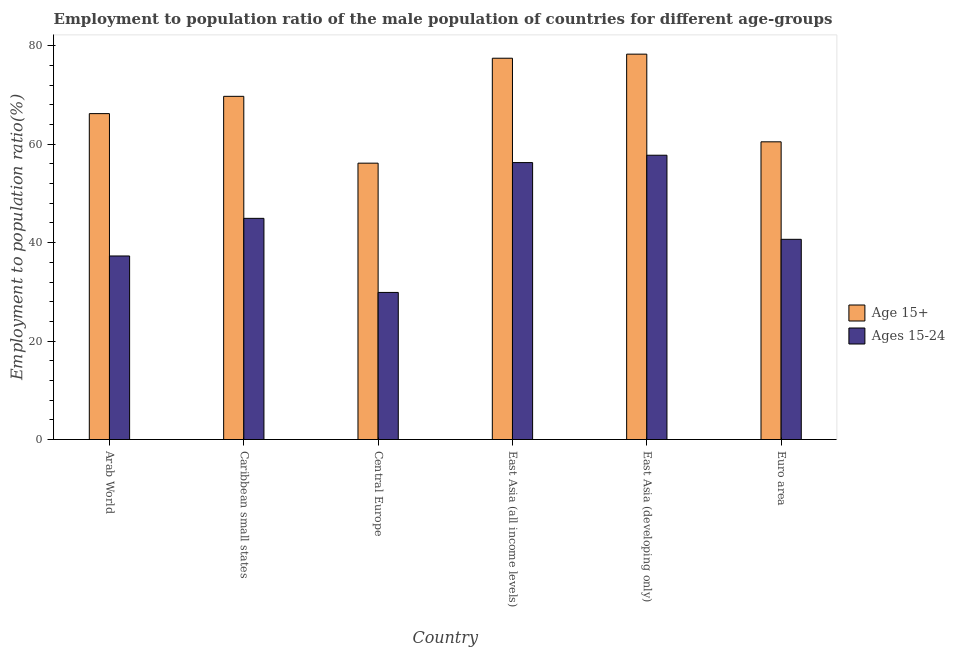How many different coloured bars are there?
Make the answer very short. 2. Are the number of bars on each tick of the X-axis equal?
Your answer should be very brief. Yes. How many bars are there on the 5th tick from the left?
Your answer should be very brief. 2. What is the label of the 2nd group of bars from the left?
Make the answer very short. Caribbean small states. In how many cases, is the number of bars for a given country not equal to the number of legend labels?
Make the answer very short. 0. What is the employment to population ratio(age 15-24) in East Asia (all income levels)?
Your response must be concise. 56.28. Across all countries, what is the maximum employment to population ratio(age 15-24)?
Give a very brief answer. 57.77. Across all countries, what is the minimum employment to population ratio(age 15+)?
Your response must be concise. 56.16. In which country was the employment to population ratio(age 15+) maximum?
Give a very brief answer. East Asia (developing only). In which country was the employment to population ratio(age 15-24) minimum?
Ensure brevity in your answer.  Central Europe. What is the total employment to population ratio(age 15-24) in the graph?
Offer a terse response. 266.87. What is the difference between the employment to population ratio(age 15-24) in Central Europe and that in East Asia (all income levels)?
Offer a terse response. -26.39. What is the difference between the employment to population ratio(age 15+) in Euro area and the employment to population ratio(age 15-24) in Caribbean small states?
Ensure brevity in your answer.  15.55. What is the average employment to population ratio(age 15-24) per country?
Offer a terse response. 44.48. What is the difference between the employment to population ratio(age 15+) and employment to population ratio(age 15-24) in Central Europe?
Provide a short and direct response. 26.27. What is the ratio of the employment to population ratio(age 15-24) in Arab World to that in East Asia (developing only)?
Your answer should be compact. 0.65. Is the difference between the employment to population ratio(age 15+) in Arab World and Caribbean small states greater than the difference between the employment to population ratio(age 15-24) in Arab World and Caribbean small states?
Provide a short and direct response. Yes. What is the difference between the highest and the second highest employment to population ratio(age 15+)?
Offer a very short reply. 0.83. What is the difference between the highest and the lowest employment to population ratio(age 15+)?
Give a very brief answer. 22.15. Is the sum of the employment to population ratio(age 15-24) in Caribbean small states and East Asia (all income levels) greater than the maximum employment to population ratio(age 15+) across all countries?
Ensure brevity in your answer.  Yes. What does the 1st bar from the left in East Asia (developing only) represents?
Your answer should be very brief. Age 15+. What does the 2nd bar from the right in East Asia (developing only) represents?
Provide a short and direct response. Age 15+. How many countries are there in the graph?
Ensure brevity in your answer.  6. Does the graph contain grids?
Offer a terse response. No. Where does the legend appear in the graph?
Give a very brief answer. Center right. How many legend labels are there?
Give a very brief answer. 2. How are the legend labels stacked?
Give a very brief answer. Vertical. What is the title of the graph?
Ensure brevity in your answer.  Employment to population ratio of the male population of countries for different age-groups. Does "Males" appear as one of the legend labels in the graph?
Give a very brief answer. No. What is the label or title of the Y-axis?
Your response must be concise. Employment to population ratio(%). What is the Employment to population ratio(%) of Age 15+ in Arab World?
Your answer should be very brief. 66.23. What is the Employment to population ratio(%) of Ages 15-24 in Arab World?
Make the answer very short. 37.3. What is the Employment to population ratio(%) in Age 15+ in Caribbean small states?
Make the answer very short. 69.74. What is the Employment to population ratio(%) of Ages 15-24 in Caribbean small states?
Ensure brevity in your answer.  44.94. What is the Employment to population ratio(%) in Age 15+ in Central Europe?
Offer a terse response. 56.16. What is the Employment to population ratio(%) of Ages 15-24 in Central Europe?
Give a very brief answer. 29.89. What is the Employment to population ratio(%) of Age 15+ in East Asia (all income levels)?
Provide a succinct answer. 77.49. What is the Employment to population ratio(%) in Ages 15-24 in East Asia (all income levels)?
Your response must be concise. 56.28. What is the Employment to population ratio(%) of Age 15+ in East Asia (developing only)?
Offer a terse response. 78.31. What is the Employment to population ratio(%) in Ages 15-24 in East Asia (developing only)?
Give a very brief answer. 57.77. What is the Employment to population ratio(%) in Age 15+ in Euro area?
Your answer should be very brief. 60.5. What is the Employment to population ratio(%) in Ages 15-24 in Euro area?
Offer a terse response. 40.68. Across all countries, what is the maximum Employment to population ratio(%) in Age 15+?
Provide a short and direct response. 78.31. Across all countries, what is the maximum Employment to population ratio(%) of Ages 15-24?
Ensure brevity in your answer.  57.77. Across all countries, what is the minimum Employment to population ratio(%) in Age 15+?
Offer a very short reply. 56.16. Across all countries, what is the minimum Employment to population ratio(%) in Ages 15-24?
Offer a very short reply. 29.89. What is the total Employment to population ratio(%) in Age 15+ in the graph?
Make the answer very short. 408.43. What is the total Employment to population ratio(%) in Ages 15-24 in the graph?
Ensure brevity in your answer.  266.87. What is the difference between the Employment to population ratio(%) of Age 15+ in Arab World and that in Caribbean small states?
Your answer should be very brief. -3.51. What is the difference between the Employment to population ratio(%) of Ages 15-24 in Arab World and that in Caribbean small states?
Make the answer very short. -7.65. What is the difference between the Employment to population ratio(%) of Age 15+ in Arab World and that in Central Europe?
Give a very brief answer. 10.07. What is the difference between the Employment to population ratio(%) in Ages 15-24 in Arab World and that in Central Europe?
Keep it short and to the point. 7.41. What is the difference between the Employment to population ratio(%) of Age 15+ in Arab World and that in East Asia (all income levels)?
Your answer should be compact. -11.26. What is the difference between the Employment to population ratio(%) in Ages 15-24 in Arab World and that in East Asia (all income levels)?
Your response must be concise. -18.98. What is the difference between the Employment to population ratio(%) of Age 15+ in Arab World and that in East Asia (developing only)?
Your response must be concise. -12.09. What is the difference between the Employment to population ratio(%) in Ages 15-24 in Arab World and that in East Asia (developing only)?
Ensure brevity in your answer.  -20.47. What is the difference between the Employment to population ratio(%) of Age 15+ in Arab World and that in Euro area?
Give a very brief answer. 5.73. What is the difference between the Employment to population ratio(%) in Ages 15-24 in Arab World and that in Euro area?
Offer a terse response. -3.39. What is the difference between the Employment to population ratio(%) in Age 15+ in Caribbean small states and that in Central Europe?
Your response must be concise. 13.58. What is the difference between the Employment to population ratio(%) in Ages 15-24 in Caribbean small states and that in Central Europe?
Make the answer very short. 15.05. What is the difference between the Employment to population ratio(%) in Age 15+ in Caribbean small states and that in East Asia (all income levels)?
Provide a succinct answer. -7.74. What is the difference between the Employment to population ratio(%) in Ages 15-24 in Caribbean small states and that in East Asia (all income levels)?
Ensure brevity in your answer.  -11.33. What is the difference between the Employment to population ratio(%) of Age 15+ in Caribbean small states and that in East Asia (developing only)?
Make the answer very short. -8.57. What is the difference between the Employment to population ratio(%) of Ages 15-24 in Caribbean small states and that in East Asia (developing only)?
Give a very brief answer. -12.83. What is the difference between the Employment to population ratio(%) of Age 15+ in Caribbean small states and that in Euro area?
Your answer should be compact. 9.24. What is the difference between the Employment to population ratio(%) of Ages 15-24 in Caribbean small states and that in Euro area?
Provide a short and direct response. 4.26. What is the difference between the Employment to population ratio(%) in Age 15+ in Central Europe and that in East Asia (all income levels)?
Keep it short and to the point. -21.32. What is the difference between the Employment to population ratio(%) of Ages 15-24 in Central Europe and that in East Asia (all income levels)?
Offer a very short reply. -26.39. What is the difference between the Employment to population ratio(%) in Age 15+ in Central Europe and that in East Asia (developing only)?
Provide a short and direct response. -22.15. What is the difference between the Employment to population ratio(%) of Ages 15-24 in Central Europe and that in East Asia (developing only)?
Provide a succinct answer. -27.88. What is the difference between the Employment to population ratio(%) in Age 15+ in Central Europe and that in Euro area?
Give a very brief answer. -4.34. What is the difference between the Employment to population ratio(%) in Ages 15-24 in Central Europe and that in Euro area?
Your answer should be compact. -10.79. What is the difference between the Employment to population ratio(%) of Age 15+ in East Asia (all income levels) and that in East Asia (developing only)?
Keep it short and to the point. -0.83. What is the difference between the Employment to population ratio(%) in Ages 15-24 in East Asia (all income levels) and that in East Asia (developing only)?
Offer a very short reply. -1.49. What is the difference between the Employment to population ratio(%) in Age 15+ in East Asia (all income levels) and that in Euro area?
Provide a succinct answer. 16.99. What is the difference between the Employment to population ratio(%) of Ages 15-24 in East Asia (all income levels) and that in Euro area?
Your answer should be compact. 15.59. What is the difference between the Employment to population ratio(%) of Age 15+ in East Asia (developing only) and that in Euro area?
Provide a short and direct response. 17.82. What is the difference between the Employment to population ratio(%) in Ages 15-24 in East Asia (developing only) and that in Euro area?
Keep it short and to the point. 17.09. What is the difference between the Employment to population ratio(%) of Age 15+ in Arab World and the Employment to population ratio(%) of Ages 15-24 in Caribbean small states?
Your response must be concise. 21.28. What is the difference between the Employment to population ratio(%) in Age 15+ in Arab World and the Employment to population ratio(%) in Ages 15-24 in Central Europe?
Offer a very short reply. 36.34. What is the difference between the Employment to population ratio(%) in Age 15+ in Arab World and the Employment to population ratio(%) in Ages 15-24 in East Asia (all income levels)?
Offer a very short reply. 9.95. What is the difference between the Employment to population ratio(%) in Age 15+ in Arab World and the Employment to population ratio(%) in Ages 15-24 in East Asia (developing only)?
Offer a terse response. 8.46. What is the difference between the Employment to population ratio(%) of Age 15+ in Arab World and the Employment to population ratio(%) of Ages 15-24 in Euro area?
Provide a succinct answer. 25.54. What is the difference between the Employment to population ratio(%) of Age 15+ in Caribbean small states and the Employment to population ratio(%) of Ages 15-24 in Central Europe?
Provide a succinct answer. 39.85. What is the difference between the Employment to population ratio(%) of Age 15+ in Caribbean small states and the Employment to population ratio(%) of Ages 15-24 in East Asia (all income levels)?
Offer a very short reply. 13.46. What is the difference between the Employment to population ratio(%) in Age 15+ in Caribbean small states and the Employment to population ratio(%) in Ages 15-24 in East Asia (developing only)?
Offer a very short reply. 11.97. What is the difference between the Employment to population ratio(%) in Age 15+ in Caribbean small states and the Employment to population ratio(%) in Ages 15-24 in Euro area?
Ensure brevity in your answer.  29.06. What is the difference between the Employment to population ratio(%) of Age 15+ in Central Europe and the Employment to population ratio(%) of Ages 15-24 in East Asia (all income levels)?
Provide a succinct answer. -0.12. What is the difference between the Employment to population ratio(%) of Age 15+ in Central Europe and the Employment to population ratio(%) of Ages 15-24 in East Asia (developing only)?
Provide a short and direct response. -1.61. What is the difference between the Employment to population ratio(%) in Age 15+ in Central Europe and the Employment to population ratio(%) in Ages 15-24 in Euro area?
Give a very brief answer. 15.48. What is the difference between the Employment to population ratio(%) in Age 15+ in East Asia (all income levels) and the Employment to population ratio(%) in Ages 15-24 in East Asia (developing only)?
Give a very brief answer. 19.71. What is the difference between the Employment to population ratio(%) of Age 15+ in East Asia (all income levels) and the Employment to population ratio(%) of Ages 15-24 in Euro area?
Ensure brevity in your answer.  36.8. What is the difference between the Employment to population ratio(%) in Age 15+ in East Asia (developing only) and the Employment to population ratio(%) in Ages 15-24 in Euro area?
Make the answer very short. 37.63. What is the average Employment to population ratio(%) of Age 15+ per country?
Offer a terse response. 68.07. What is the average Employment to population ratio(%) in Ages 15-24 per country?
Offer a terse response. 44.48. What is the difference between the Employment to population ratio(%) of Age 15+ and Employment to population ratio(%) of Ages 15-24 in Arab World?
Ensure brevity in your answer.  28.93. What is the difference between the Employment to population ratio(%) of Age 15+ and Employment to population ratio(%) of Ages 15-24 in Caribbean small states?
Ensure brevity in your answer.  24.8. What is the difference between the Employment to population ratio(%) of Age 15+ and Employment to population ratio(%) of Ages 15-24 in Central Europe?
Give a very brief answer. 26.27. What is the difference between the Employment to population ratio(%) in Age 15+ and Employment to population ratio(%) in Ages 15-24 in East Asia (all income levels)?
Offer a terse response. 21.21. What is the difference between the Employment to population ratio(%) of Age 15+ and Employment to population ratio(%) of Ages 15-24 in East Asia (developing only)?
Your answer should be compact. 20.54. What is the difference between the Employment to population ratio(%) in Age 15+ and Employment to population ratio(%) in Ages 15-24 in Euro area?
Your answer should be very brief. 19.81. What is the ratio of the Employment to population ratio(%) in Age 15+ in Arab World to that in Caribbean small states?
Provide a short and direct response. 0.95. What is the ratio of the Employment to population ratio(%) of Ages 15-24 in Arab World to that in Caribbean small states?
Provide a short and direct response. 0.83. What is the ratio of the Employment to population ratio(%) of Age 15+ in Arab World to that in Central Europe?
Provide a short and direct response. 1.18. What is the ratio of the Employment to population ratio(%) of Ages 15-24 in Arab World to that in Central Europe?
Offer a terse response. 1.25. What is the ratio of the Employment to population ratio(%) in Age 15+ in Arab World to that in East Asia (all income levels)?
Provide a succinct answer. 0.85. What is the ratio of the Employment to population ratio(%) of Ages 15-24 in Arab World to that in East Asia (all income levels)?
Your response must be concise. 0.66. What is the ratio of the Employment to population ratio(%) in Age 15+ in Arab World to that in East Asia (developing only)?
Your answer should be compact. 0.85. What is the ratio of the Employment to population ratio(%) of Ages 15-24 in Arab World to that in East Asia (developing only)?
Your answer should be compact. 0.65. What is the ratio of the Employment to population ratio(%) of Age 15+ in Arab World to that in Euro area?
Your response must be concise. 1.09. What is the ratio of the Employment to population ratio(%) of Ages 15-24 in Arab World to that in Euro area?
Keep it short and to the point. 0.92. What is the ratio of the Employment to population ratio(%) in Age 15+ in Caribbean small states to that in Central Europe?
Your answer should be compact. 1.24. What is the ratio of the Employment to population ratio(%) of Ages 15-24 in Caribbean small states to that in Central Europe?
Ensure brevity in your answer.  1.5. What is the ratio of the Employment to population ratio(%) of Age 15+ in Caribbean small states to that in East Asia (all income levels)?
Your answer should be compact. 0.9. What is the ratio of the Employment to population ratio(%) in Ages 15-24 in Caribbean small states to that in East Asia (all income levels)?
Provide a succinct answer. 0.8. What is the ratio of the Employment to population ratio(%) of Age 15+ in Caribbean small states to that in East Asia (developing only)?
Give a very brief answer. 0.89. What is the ratio of the Employment to population ratio(%) in Ages 15-24 in Caribbean small states to that in East Asia (developing only)?
Provide a succinct answer. 0.78. What is the ratio of the Employment to population ratio(%) of Age 15+ in Caribbean small states to that in Euro area?
Your response must be concise. 1.15. What is the ratio of the Employment to population ratio(%) in Ages 15-24 in Caribbean small states to that in Euro area?
Your answer should be very brief. 1.1. What is the ratio of the Employment to population ratio(%) in Age 15+ in Central Europe to that in East Asia (all income levels)?
Your answer should be very brief. 0.72. What is the ratio of the Employment to population ratio(%) in Ages 15-24 in Central Europe to that in East Asia (all income levels)?
Offer a very short reply. 0.53. What is the ratio of the Employment to population ratio(%) in Age 15+ in Central Europe to that in East Asia (developing only)?
Offer a terse response. 0.72. What is the ratio of the Employment to population ratio(%) in Ages 15-24 in Central Europe to that in East Asia (developing only)?
Offer a very short reply. 0.52. What is the ratio of the Employment to population ratio(%) in Age 15+ in Central Europe to that in Euro area?
Provide a succinct answer. 0.93. What is the ratio of the Employment to population ratio(%) in Ages 15-24 in Central Europe to that in Euro area?
Your answer should be compact. 0.73. What is the ratio of the Employment to population ratio(%) of Age 15+ in East Asia (all income levels) to that in East Asia (developing only)?
Ensure brevity in your answer.  0.99. What is the ratio of the Employment to population ratio(%) in Ages 15-24 in East Asia (all income levels) to that in East Asia (developing only)?
Ensure brevity in your answer.  0.97. What is the ratio of the Employment to population ratio(%) of Age 15+ in East Asia (all income levels) to that in Euro area?
Keep it short and to the point. 1.28. What is the ratio of the Employment to population ratio(%) of Ages 15-24 in East Asia (all income levels) to that in Euro area?
Offer a very short reply. 1.38. What is the ratio of the Employment to population ratio(%) of Age 15+ in East Asia (developing only) to that in Euro area?
Offer a very short reply. 1.29. What is the ratio of the Employment to population ratio(%) in Ages 15-24 in East Asia (developing only) to that in Euro area?
Offer a very short reply. 1.42. What is the difference between the highest and the second highest Employment to population ratio(%) of Age 15+?
Provide a short and direct response. 0.83. What is the difference between the highest and the second highest Employment to population ratio(%) of Ages 15-24?
Offer a very short reply. 1.49. What is the difference between the highest and the lowest Employment to population ratio(%) in Age 15+?
Keep it short and to the point. 22.15. What is the difference between the highest and the lowest Employment to population ratio(%) in Ages 15-24?
Give a very brief answer. 27.88. 